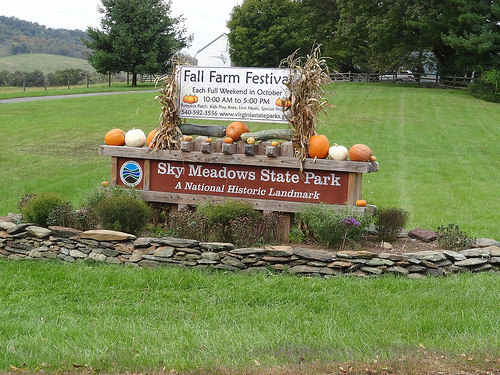<image>
Is there a tree behind the fence? No. The tree is not behind the fence. From this viewpoint, the tree appears to be positioned elsewhere in the scene. 